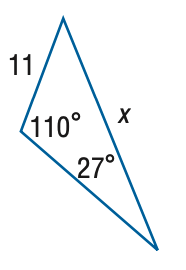Question: Find x. Round side measure to the nearest tenth.
Choices:
A. 5.3
B. 7.3
C. 16.5
D. 22.8
Answer with the letter. Answer: D 